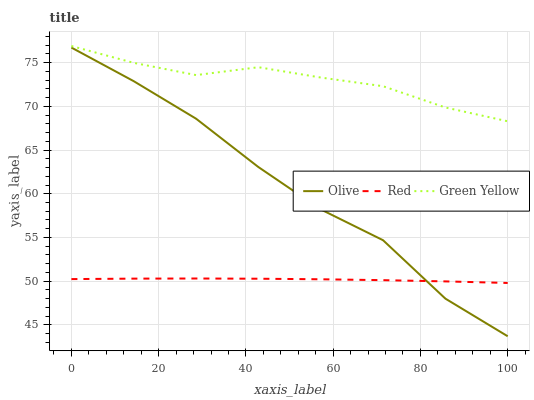Does Red have the minimum area under the curve?
Answer yes or no. Yes. Does Green Yellow have the maximum area under the curve?
Answer yes or no. Yes. Does Green Yellow have the minimum area under the curve?
Answer yes or no. No. Does Red have the maximum area under the curve?
Answer yes or no. No. Is Red the smoothest?
Answer yes or no. Yes. Is Olive the roughest?
Answer yes or no. Yes. Is Green Yellow the smoothest?
Answer yes or no. No. Is Green Yellow the roughest?
Answer yes or no. No. Does Olive have the lowest value?
Answer yes or no. Yes. Does Red have the lowest value?
Answer yes or no. No. Does Green Yellow have the highest value?
Answer yes or no. Yes. Does Red have the highest value?
Answer yes or no. No. Is Olive less than Green Yellow?
Answer yes or no. Yes. Is Green Yellow greater than Olive?
Answer yes or no. Yes. Does Olive intersect Red?
Answer yes or no. Yes. Is Olive less than Red?
Answer yes or no. No. Is Olive greater than Red?
Answer yes or no. No. Does Olive intersect Green Yellow?
Answer yes or no. No. 